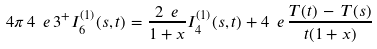<formula> <loc_0><loc_0><loc_500><loc_500>4 \pi \, 4 \ e \, 3 ^ { + } I _ { 6 } ^ { ( 1 ) } ( s , t ) = \frac { 2 \ e } { 1 + x } I _ { 4 } ^ { ( 1 ) } ( s , t ) + 4 \ e \, \frac { T ( t ) \, - \, T ( s ) } { t ( 1 + x ) }</formula> 